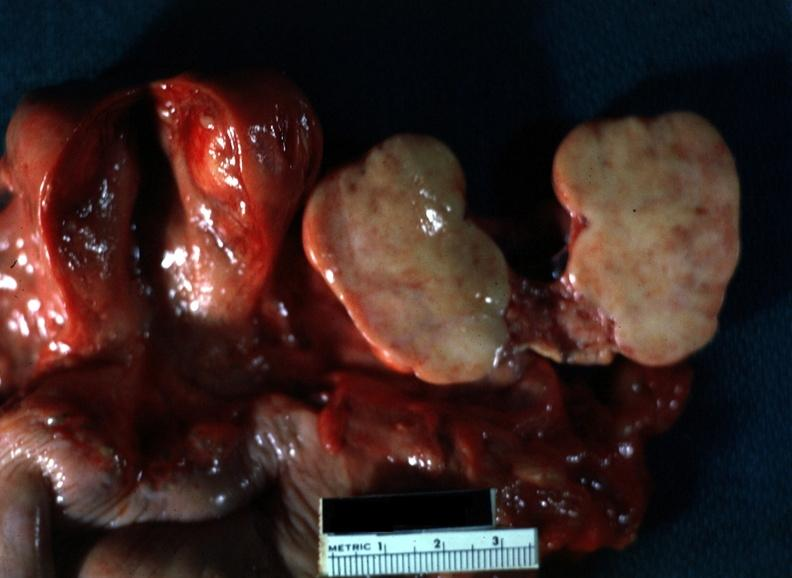what is close-up of lesion sliced?
Answer the question using a single word or phrase. Lesion sliced open like a book typical for this with yellow foci evident view all pelvic organ in slide 